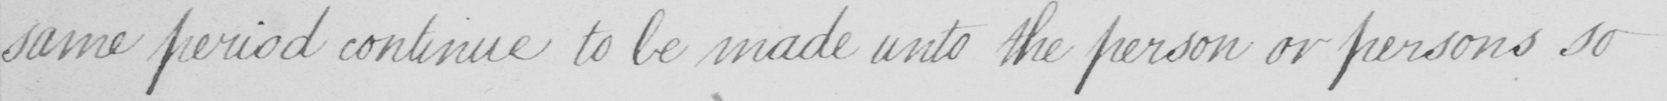Please provide the text content of this handwritten line. same period continue to be made unto the person or persons so 